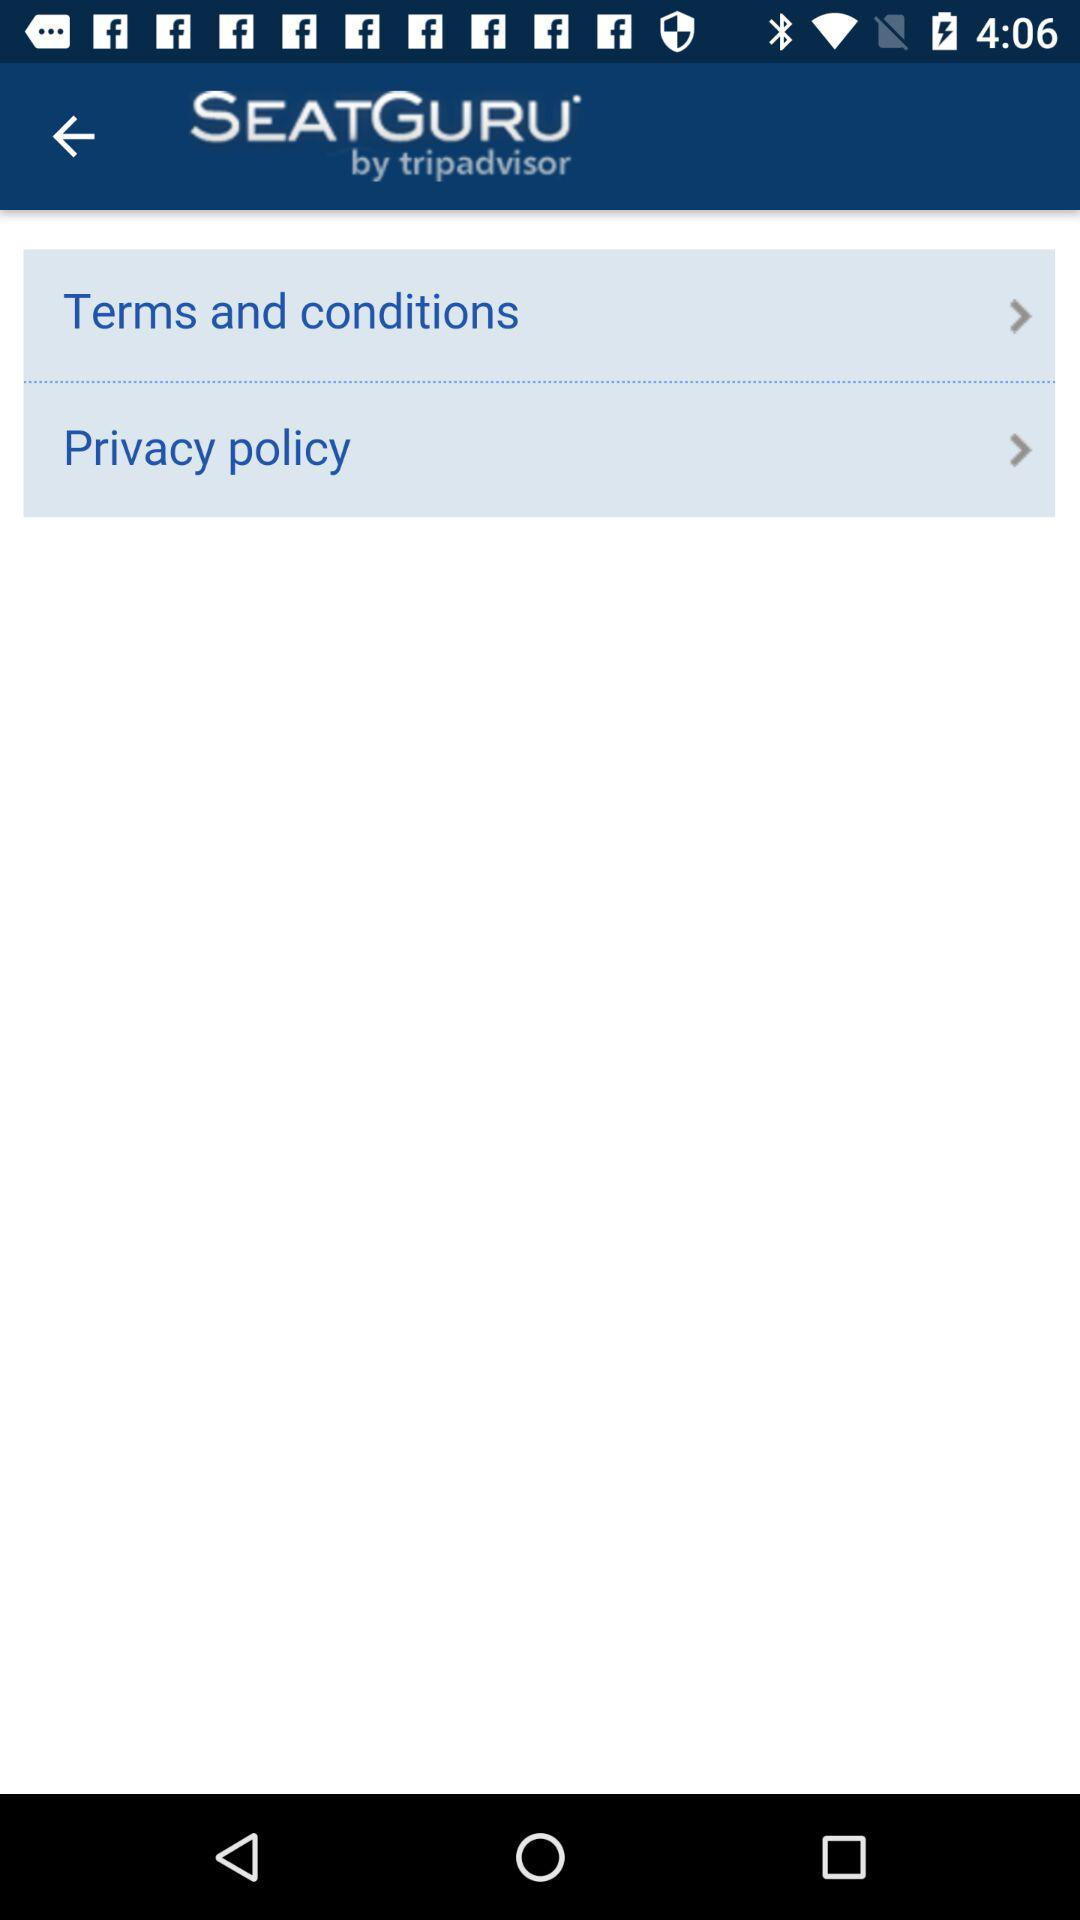What is the name of the application? The name of the application is "SEATGURU". 